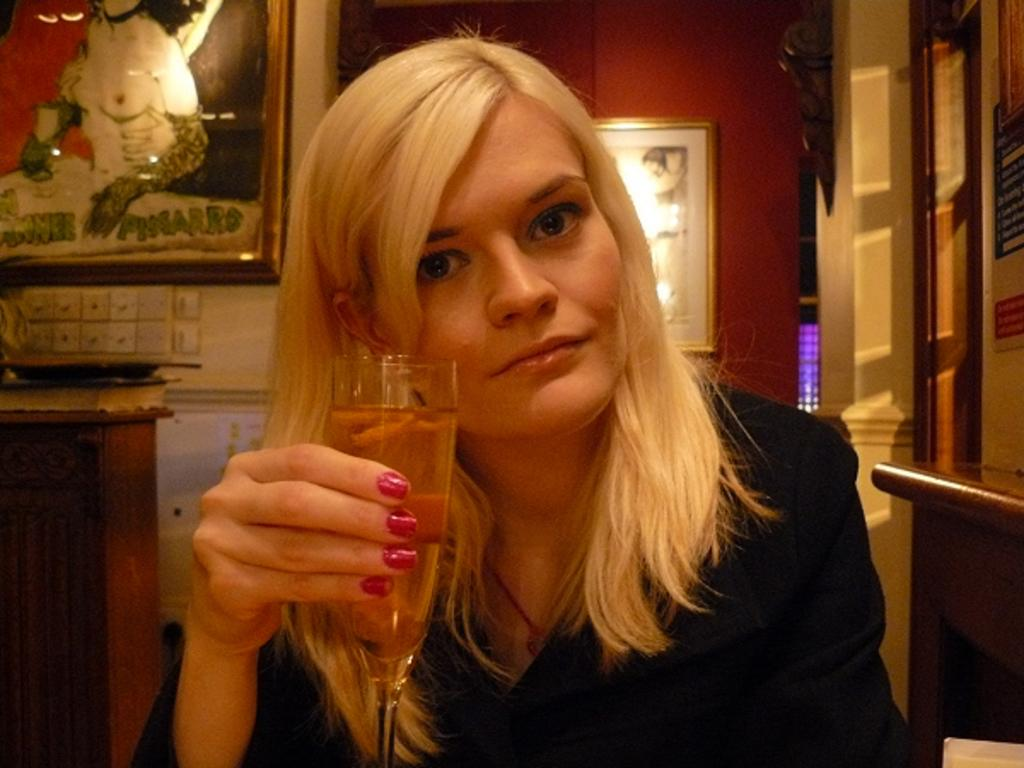Who is the main subject in the image? There is a woman in the image. What is the woman doing in the image? The woman is posing for the camera. What is the woman holding in her hand? The woman is holding a wine glass in her hand. What is the woman wearing in the image? The woman is wearing a black color suit. What can be seen in the background of the image? There are paintings in the background of the image. What discovery did the woman make while holding the wine glass in the image? There is no indication of a discovery in the image; the woman is simply posing for the camera while holding a wine glass. 